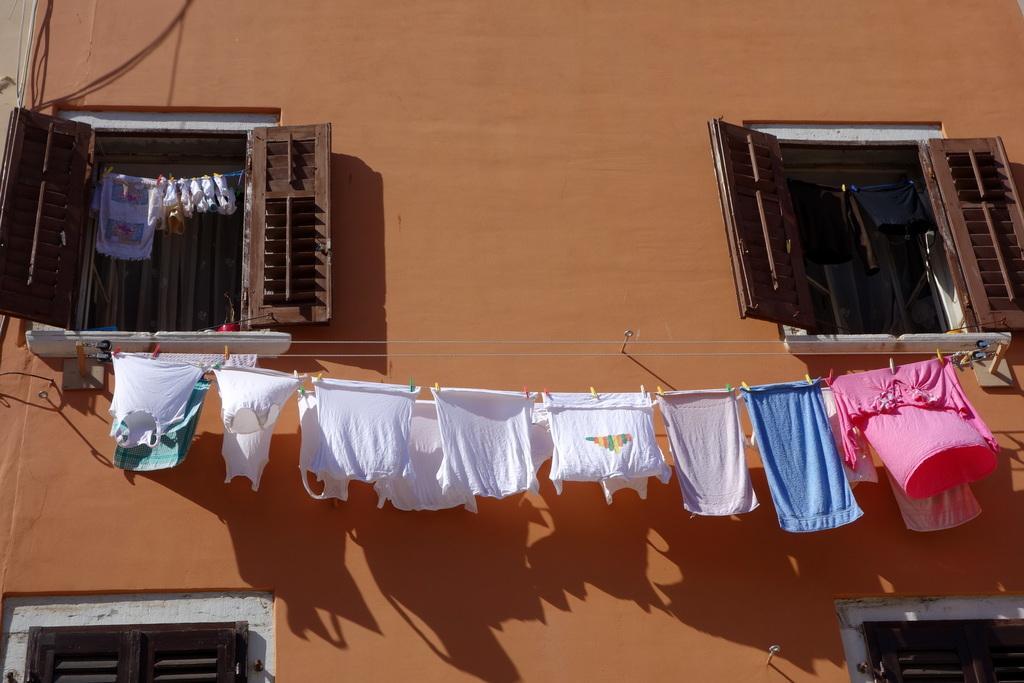Describe this image in one or two sentences. We can see clothes hanging on rope and we can see clips. We can see wall,cables and windows. 